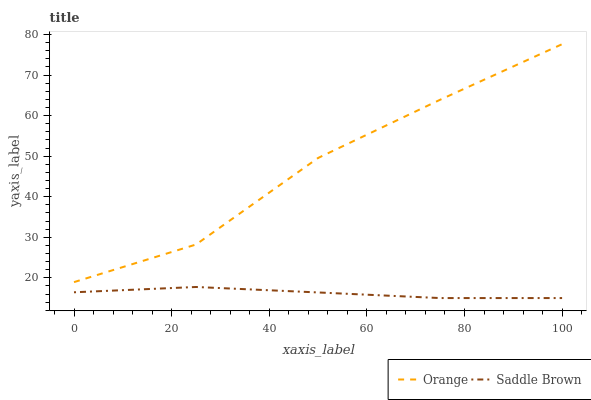Does Saddle Brown have the minimum area under the curve?
Answer yes or no. Yes. Does Orange have the maximum area under the curve?
Answer yes or no. Yes. Does Saddle Brown have the maximum area under the curve?
Answer yes or no. No. Is Saddle Brown the smoothest?
Answer yes or no. Yes. Is Orange the roughest?
Answer yes or no. Yes. Is Saddle Brown the roughest?
Answer yes or no. No. Does Saddle Brown have the lowest value?
Answer yes or no. Yes. Does Orange have the highest value?
Answer yes or no. Yes. Does Saddle Brown have the highest value?
Answer yes or no. No. Is Saddle Brown less than Orange?
Answer yes or no. Yes. Is Orange greater than Saddle Brown?
Answer yes or no. Yes. Does Saddle Brown intersect Orange?
Answer yes or no. No. 